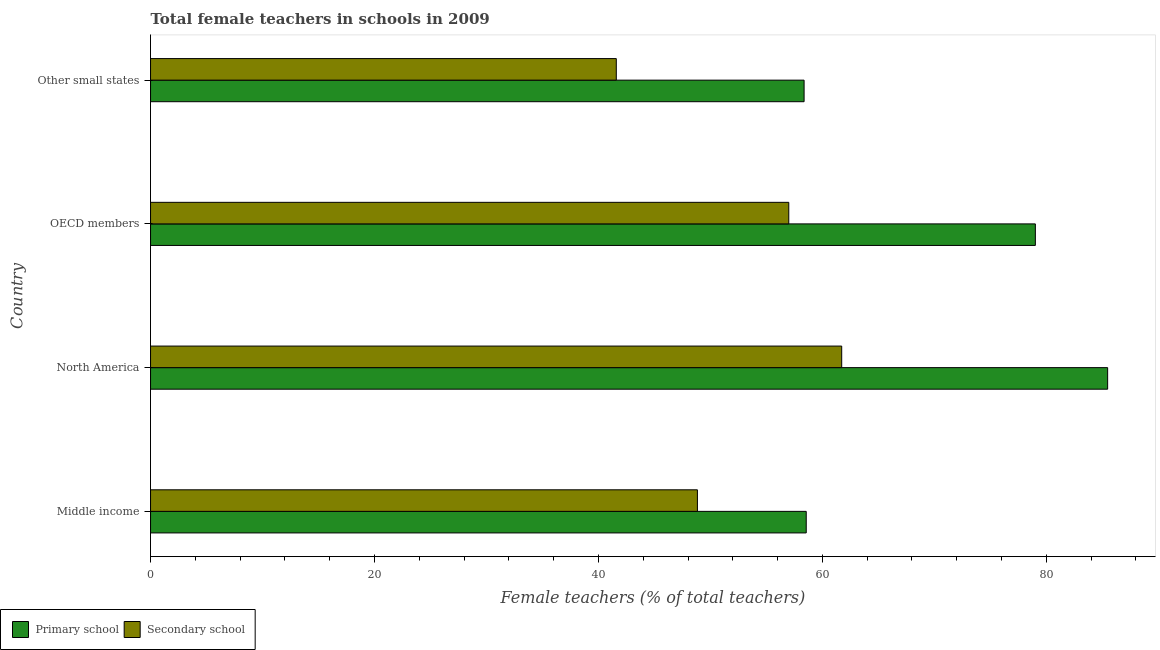How many different coloured bars are there?
Your response must be concise. 2. Are the number of bars per tick equal to the number of legend labels?
Your response must be concise. Yes. Are the number of bars on each tick of the Y-axis equal?
Offer a terse response. Yes. How many bars are there on the 4th tick from the bottom?
Your response must be concise. 2. In how many cases, is the number of bars for a given country not equal to the number of legend labels?
Provide a short and direct response. 0. What is the percentage of female teachers in secondary schools in Other small states?
Your answer should be very brief. 41.6. Across all countries, what is the maximum percentage of female teachers in secondary schools?
Provide a short and direct response. 61.73. Across all countries, what is the minimum percentage of female teachers in secondary schools?
Offer a very short reply. 41.6. In which country was the percentage of female teachers in secondary schools minimum?
Your answer should be very brief. Other small states. What is the total percentage of female teachers in secondary schools in the graph?
Keep it short and to the point. 209.16. What is the difference between the percentage of female teachers in primary schools in Middle income and that in North America?
Your answer should be compact. -26.92. What is the difference between the percentage of female teachers in primary schools in Middle income and the percentage of female teachers in secondary schools in North America?
Keep it short and to the point. -3.17. What is the average percentage of female teachers in primary schools per country?
Your answer should be very brief. 70.36. What is the difference between the percentage of female teachers in primary schools and percentage of female teachers in secondary schools in OECD members?
Keep it short and to the point. 22.02. What is the ratio of the percentage of female teachers in secondary schools in Middle income to that in OECD members?
Keep it short and to the point. 0.86. What is the difference between the highest and the second highest percentage of female teachers in primary schools?
Your response must be concise. 6.46. What is the difference between the highest and the lowest percentage of female teachers in primary schools?
Offer a very short reply. 27.11. Is the sum of the percentage of female teachers in secondary schools in Middle income and North America greater than the maximum percentage of female teachers in primary schools across all countries?
Make the answer very short. Yes. What does the 1st bar from the top in Middle income represents?
Make the answer very short. Secondary school. What does the 1st bar from the bottom in OECD members represents?
Offer a terse response. Primary school. How many bars are there?
Keep it short and to the point. 8. Are all the bars in the graph horizontal?
Your response must be concise. Yes. Are the values on the major ticks of X-axis written in scientific E-notation?
Your response must be concise. No. Does the graph contain grids?
Provide a succinct answer. No. How are the legend labels stacked?
Offer a terse response. Horizontal. What is the title of the graph?
Offer a very short reply. Total female teachers in schools in 2009. Does "Public funds" appear as one of the legend labels in the graph?
Offer a terse response. No. What is the label or title of the X-axis?
Provide a succinct answer. Female teachers (% of total teachers). What is the label or title of the Y-axis?
Keep it short and to the point. Country. What is the Female teachers (% of total teachers) of Primary school in Middle income?
Offer a very short reply. 58.56. What is the Female teachers (% of total teachers) of Secondary school in Middle income?
Your answer should be compact. 48.84. What is the Female teachers (% of total teachers) of Primary school in North America?
Offer a very short reply. 85.48. What is the Female teachers (% of total teachers) of Secondary school in North America?
Your answer should be compact. 61.73. What is the Female teachers (% of total teachers) in Primary school in OECD members?
Provide a short and direct response. 79.02. What is the Female teachers (% of total teachers) of Secondary school in OECD members?
Provide a short and direct response. 57. What is the Female teachers (% of total teachers) of Primary school in Other small states?
Your answer should be compact. 58.37. What is the Female teachers (% of total teachers) of Secondary school in Other small states?
Your answer should be very brief. 41.6. Across all countries, what is the maximum Female teachers (% of total teachers) of Primary school?
Your answer should be very brief. 85.48. Across all countries, what is the maximum Female teachers (% of total teachers) in Secondary school?
Your answer should be compact. 61.73. Across all countries, what is the minimum Female teachers (% of total teachers) of Primary school?
Ensure brevity in your answer.  58.37. Across all countries, what is the minimum Female teachers (% of total teachers) of Secondary school?
Provide a short and direct response. 41.6. What is the total Female teachers (% of total teachers) in Primary school in the graph?
Provide a short and direct response. 281.42. What is the total Female teachers (% of total teachers) in Secondary school in the graph?
Keep it short and to the point. 209.16. What is the difference between the Female teachers (% of total teachers) in Primary school in Middle income and that in North America?
Give a very brief answer. -26.92. What is the difference between the Female teachers (% of total teachers) of Secondary school in Middle income and that in North America?
Offer a terse response. -12.89. What is the difference between the Female teachers (% of total teachers) of Primary school in Middle income and that in OECD members?
Provide a succinct answer. -20.46. What is the difference between the Female teachers (% of total teachers) of Secondary school in Middle income and that in OECD members?
Make the answer very short. -8.16. What is the difference between the Female teachers (% of total teachers) in Primary school in Middle income and that in Other small states?
Offer a very short reply. 0.19. What is the difference between the Female teachers (% of total teachers) in Secondary school in Middle income and that in Other small states?
Ensure brevity in your answer.  7.24. What is the difference between the Female teachers (% of total teachers) of Primary school in North America and that in OECD members?
Provide a succinct answer. 6.45. What is the difference between the Female teachers (% of total teachers) in Secondary school in North America and that in OECD members?
Make the answer very short. 4.73. What is the difference between the Female teachers (% of total teachers) in Primary school in North America and that in Other small states?
Make the answer very short. 27.11. What is the difference between the Female teachers (% of total teachers) in Secondary school in North America and that in Other small states?
Your response must be concise. 20.13. What is the difference between the Female teachers (% of total teachers) in Primary school in OECD members and that in Other small states?
Offer a very short reply. 20.65. What is the difference between the Female teachers (% of total teachers) in Secondary school in OECD members and that in Other small states?
Your answer should be compact. 15.4. What is the difference between the Female teachers (% of total teachers) of Primary school in Middle income and the Female teachers (% of total teachers) of Secondary school in North America?
Ensure brevity in your answer.  -3.17. What is the difference between the Female teachers (% of total teachers) of Primary school in Middle income and the Female teachers (% of total teachers) of Secondary school in OECD members?
Give a very brief answer. 1.56. What is the difference between the Female teachers (% of total teachers) in Primary school in Middle income and the Female teachers (% of total teachers) in Secondary school in Other small states?
Your answer should be very brief. 16.96. What is the difference between the Female teachers (% of total teachers) in Primary school in North America and the Female teachers (% of total teachers) in Secondary school in OECD members?
Your answer should be very brief. 28.48. What is the difference between the Female teachers (% of total teachers) in Primary school in North America and the Female teachers (% of total teachers) in Secondary school in Other small states?
Ensure brevity in your answer.  43.88. What is the difference between the Female teachers (% of total teachers) of Primary school in OECD members and the Female teachers (% of total teachers) of Secondary school in Other small states?
Your answer should be compact. 37.42. What is the average Female teachers (% of total teachers) in Primary school per country?
Keep it short and to the point. 70.36. What is the average Female teachers (% of total teachers) in Secondary school per country?
Ensure brevity in your answer.  52.29. What is the difference between the Female teachers (% of total teachers) in Primary school and Female teachers (% of total teachers) in Secondary school in Middle income?
Make the answer very short. 9.72. What is the difference between the Female teachers (% of total teachers) in Primary school and Female teachers (% of total teachers) in Secondary school in North America?
Offer a terse response. 23.75. What is the difference between the Female teachers (% of total teachers) of Primary school and Female teachers (% of total teachers) of Secondary school in OECD members?
Provide a succinct answer. 22.02. What is the difference between the Female teachers (% of total teachers) in Primary school and Female teachers (% of total teachers) in Secondary school in Other small states?
Your answer should be compact. 16.77. What is the ratio of the Female teachers (% of total teachers) of Primary school in Middle income to that in North America?
Provide a succinct answer. 0.69. What is the ratio of the Female teachers (% of total teachers) of Secondary school in Middle income to that in North America?
Your response must be concise. 0.79. What is the ratio of the Female teachers (% of total teachers) of Primary school in Middle income to that in OECD members?
Your answer should be very brief. 0.74. What is the ratio of the Female teachers (% of total teachers) in Secondary school in Middle income to that in OECD members?
Your response must be concise. 0.86. What is the ratio of the Female teachers (% of total teachers) in Secondary school in Middle income to that in Other small states?
Your response must be concise. 1.17. What is the ratio of the Female teachers (% of total teachers) of Primary school in North America to that in OECD members?
Ensure brevity in your answer.  1.08. What is the ratio of the Female teachers (% of total teachers) of Secondary school in North America to that in OECD members?
Make the answer very short. 1.08. What is the ratio of the Female teachers (% of total teachers) in Primary school in North America to that in Other small states?
Your answer should be compact. 1.46. What is the ratio of the Female teachers (% of total teachers) of Secondary school in North America to that in Other small states?
Ensure brevity in your answer.  1.48. What is the ratio of the Female teachers (% of total teachers) in Primary school in OECD members to that in Other small states?
Offer a very short reply. 1.35. What is the ratio of the Female teachers (% of total teachers) of Secondary school in OECD members to that in Other small states?
Your answer should be very brief. 1.37. What is the difference between the highest and the second highest Female teachers (% of total teachers) of Primary school?
Offer a terse response. 6.45. What is the difference between the highest and the second highest Female teachers (% of total teachers) of Secondary school?
Provide a short and direct response. 4.73. What is the difference between the highest and the lowest Female teachers (% of total teachers) in Primary school?
Give a very brief answer. 27.11. What is the difference between the highest and the lowest Female teachers (% of total teachers) in Secondary school?
Provide a short and direct response. 20.13. 